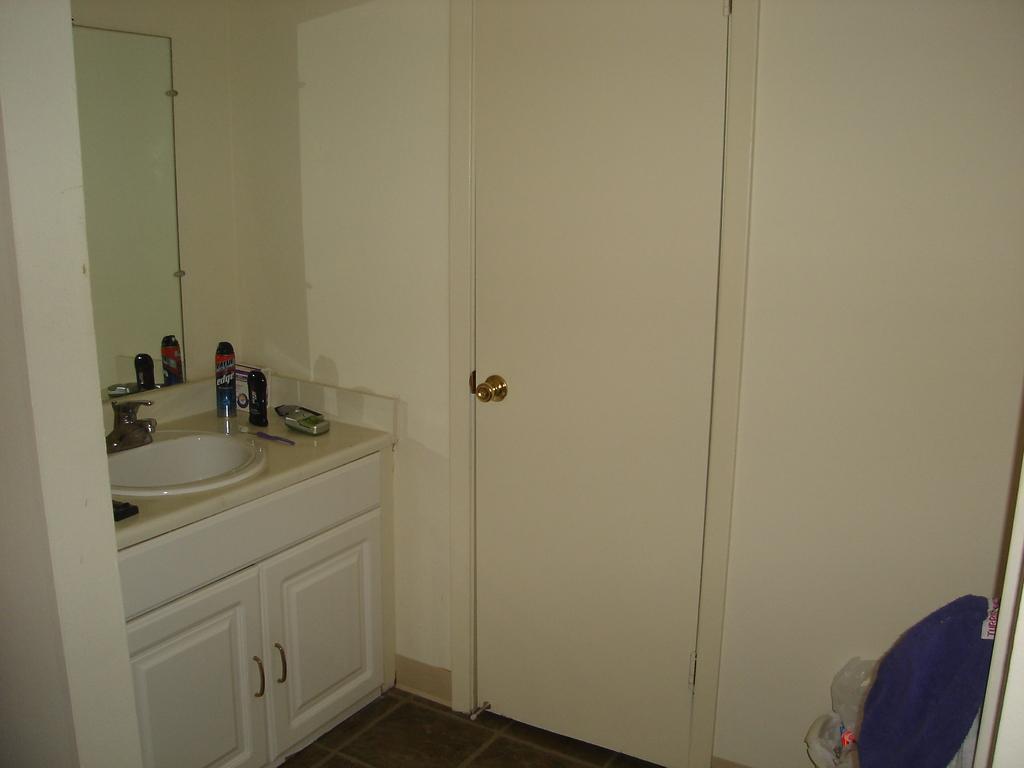In one or two sentences, can you explain what this image depicts? This is a picture of a room, in this image on the left side there is a wash basin and cupboard. And beside the washbasin there are some bottles and soap, and there is one mirror on the wall. In the center there is a door, on the right side there is wall and some objects and at the bottom there is floor. 